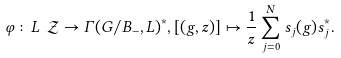Convert formula to latex. <formula><loc_0><loc_0><loc_500><loc_500>\varphi \colon L \ \mathcal { Z } \rightarrow \Gamma ( G / B _ { - } , L ) ^ { \ast } , [ ( g , z ) ] \mapsto \frac { 1 } { z } \sum _ { j = 0 } ^ { N } s _ { j } ( g ) s _ { j } ^ { \ast } .</formula> 